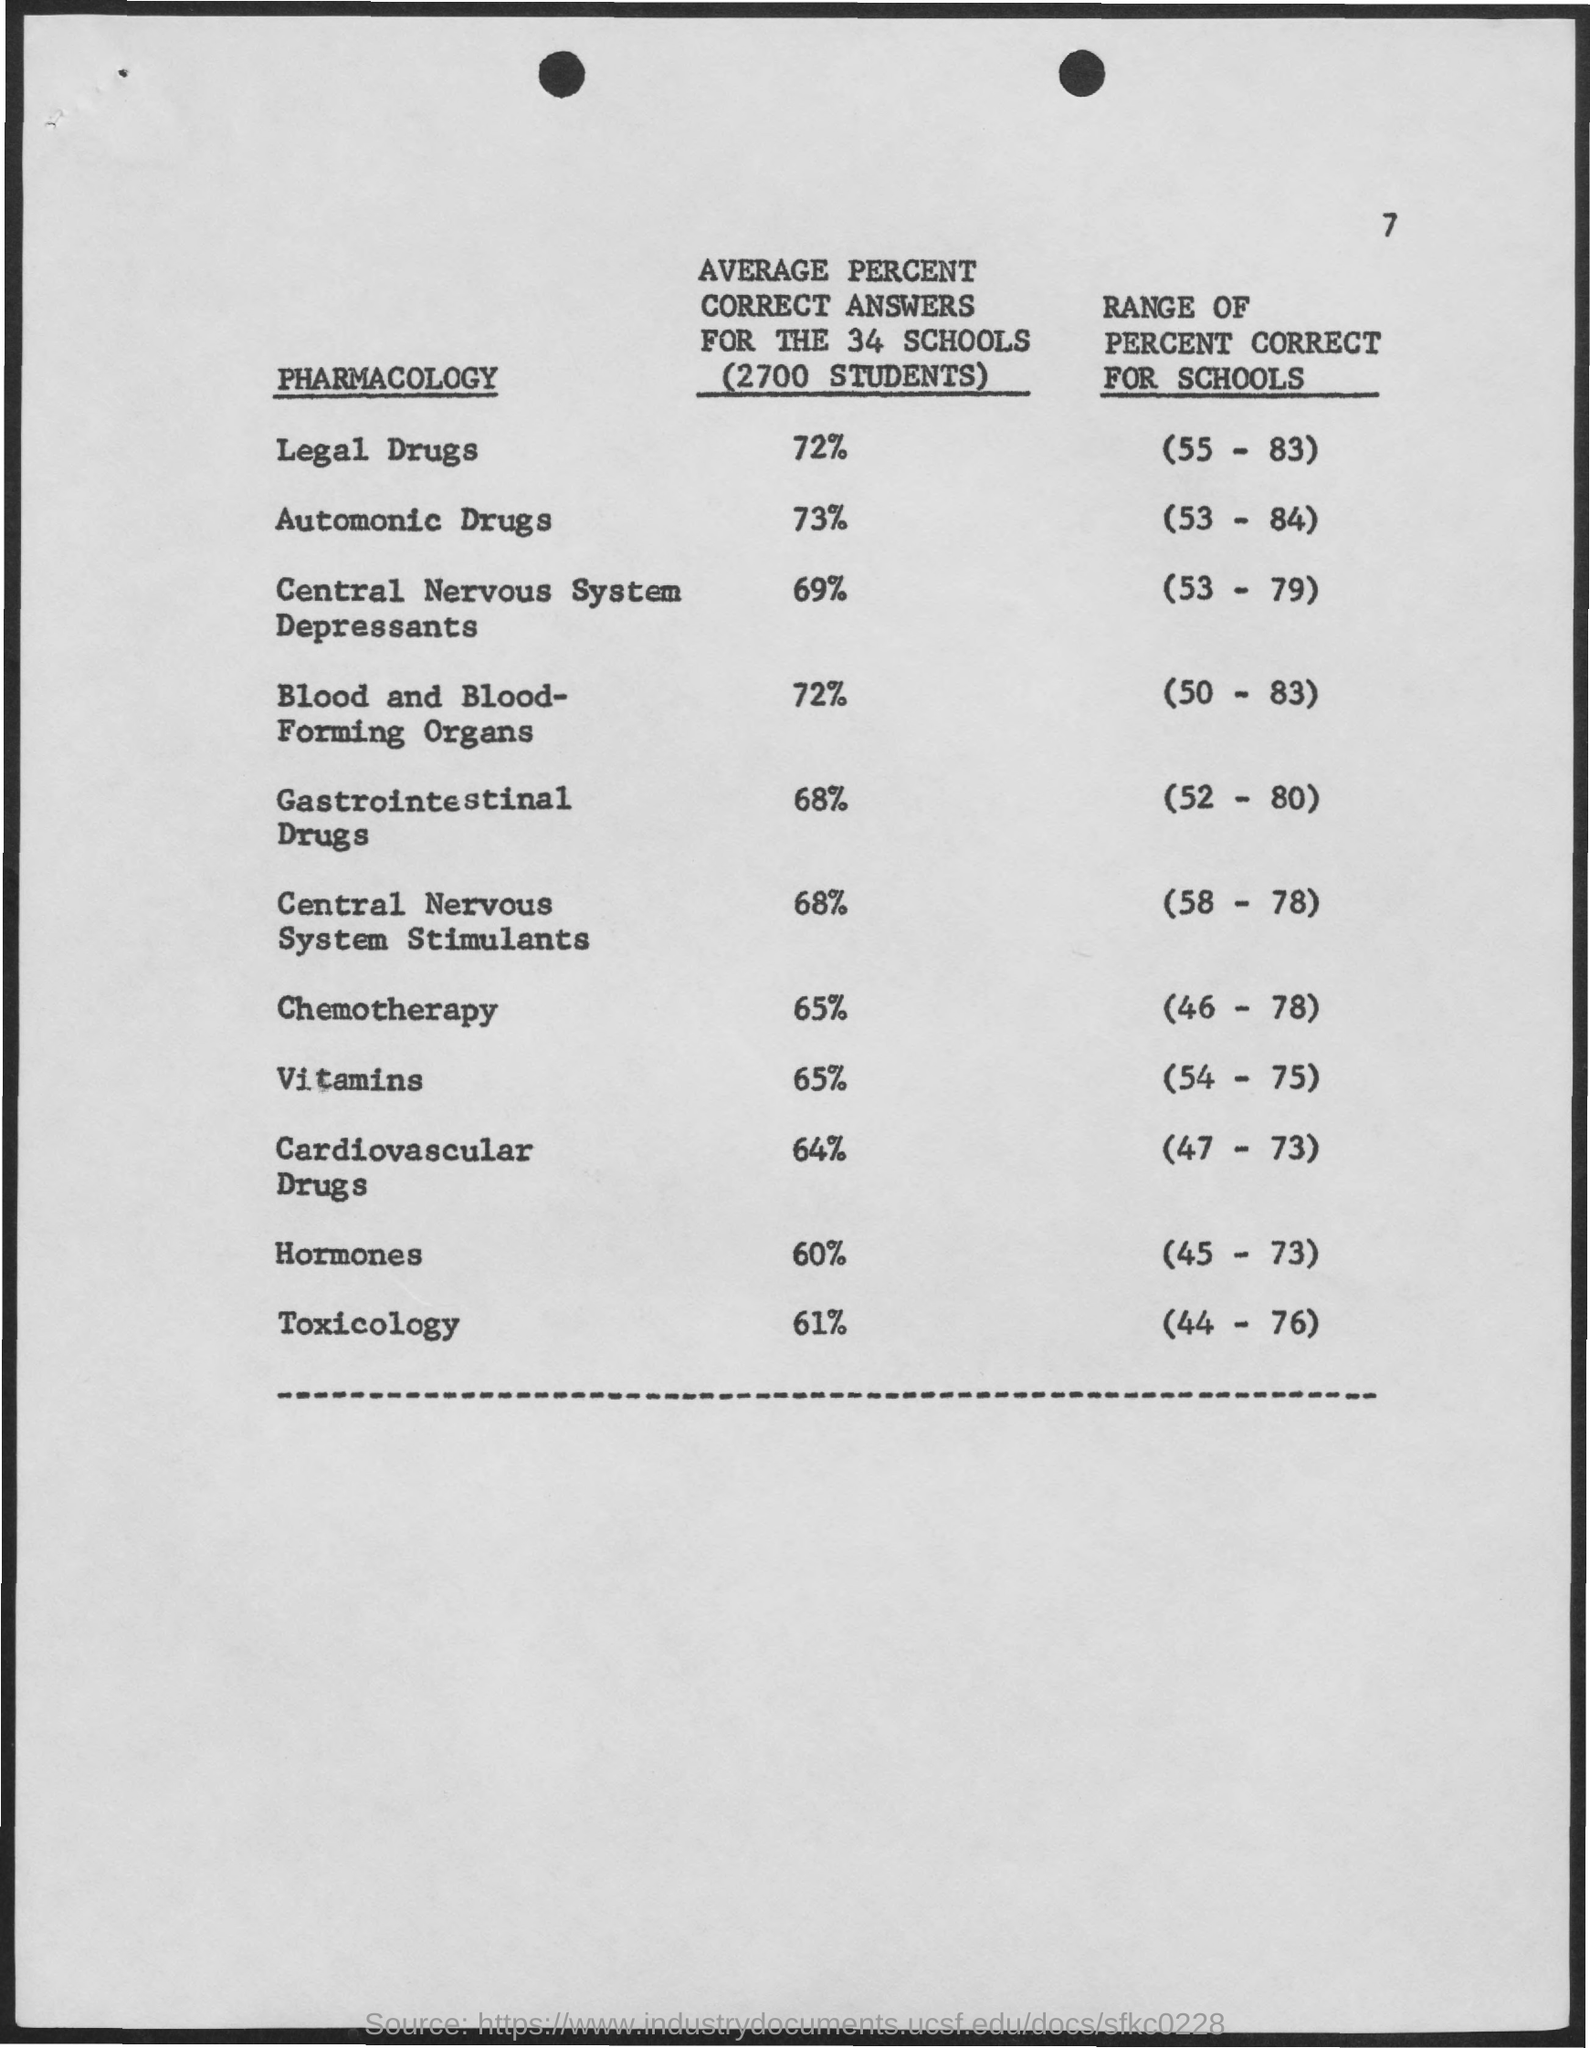Specify some key components in this picture. The average percent correct answers for the 34 schools (2700 students) for the Legal Drugs section was 72%. The average percent correct answers for the 34 schools (with 2,700 students) for the category of Cardiovascular Drugs is 64%. On average, the 34 schools had 2,700 students and achieved a score of 65% on the vitamins test. The average percent correct answers for the 34 schools (2,700 students) for the Hormones unit exam was 60%. In the study on the effectiveness of gastrointestinal drugs for 2700 students from 34 schools, the average percent correct answers was found to be 68%. 